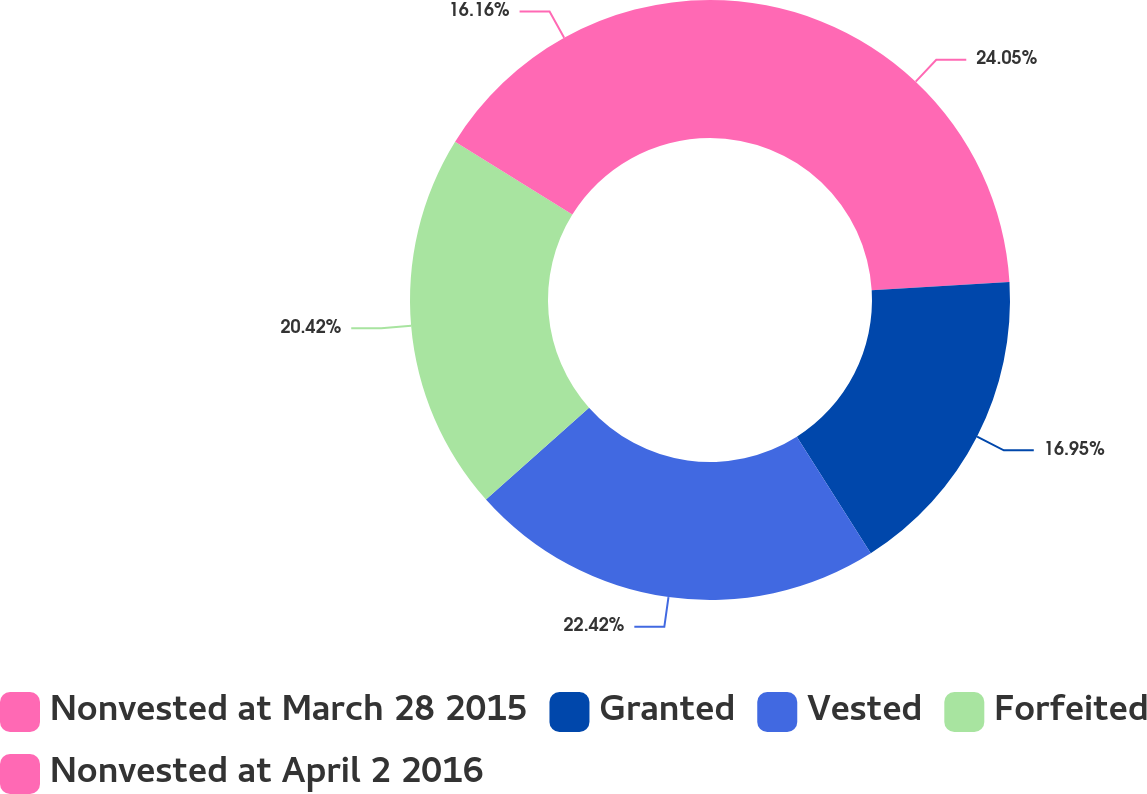Convert chart to OTSL. <chart><loc_0><loc_0><loc_500><loc_500><pie_chart><fcel>Nonvested at March 28 2015<fcel>Granted<fcel>Vested<fcel>Forfeited<fcel>Nonvested at April 2 2016<nl><fcel>24.05%<fcel>16.95%<fcel>22.42%<fcel>20.42%<fcel>16.16%<nl></chart> 